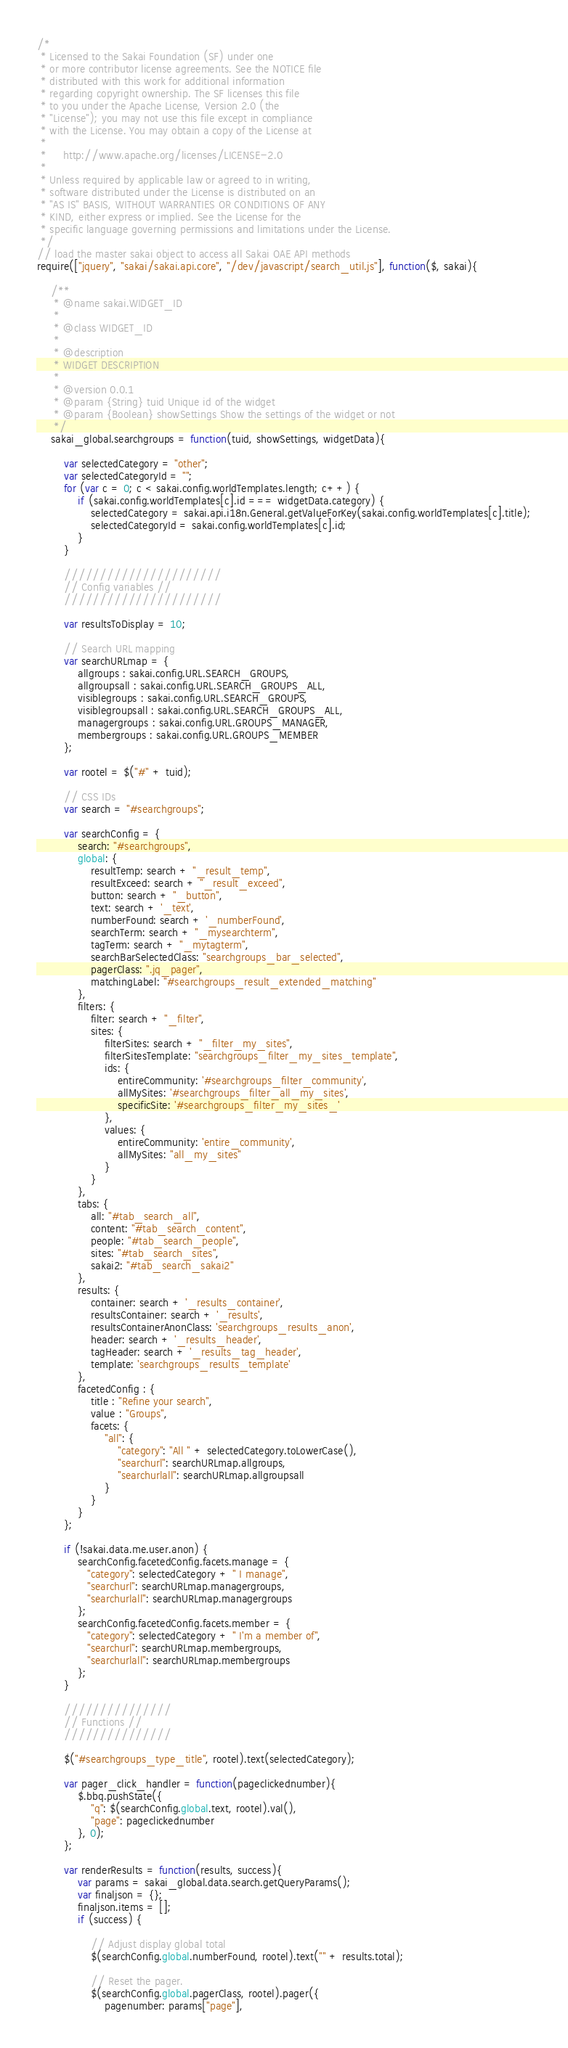Convert code to text. <code><loc_0><loc_0><loc_500><loc_500><_JavaScript_>/*
 * Licensed to the Sakai Foundation (SF) under one
 * or more contributor license agreements. See the NOTICE file
 * distributed with this work for additional information
 * regarding copyright ownership. The SF licenses this file
 * to you under the Apache License, Version 2.0 (the
 * "License"); you may not use this file except in compliance
 * with the License. You may obtain a copy of the License at
 *
 *     http://www.apache.org/licenses/LICENSE-2.0
 *
 * Unless required by applicable law or agreed to in writing,
 * software distributed under the License is distributed on an
 * "AS IS" BASIS, WITHOUT WARRANTIES OR CONDITIONS OF ANY
 * KIND, either express or implied. See the License for the
 * specific language governing permissions and limitations under the License.
 */
// load the master sakai object to access all Sakai OAE API methods
require(["jquery", "sakai/sakai.api.core", "/dev/javascript/search_util.js"], function($, sakai){

    /**
     * @name sakai.WIDGET_ID
     *
     * @class WIDGET_ID
     *
     * @description
     * WIDGET DESCRIPTION
     *
     * @version 0.0.1
     * @param {String} tuid Unique id of the widget
     * @param {Boolean} showSettings Show the settings of the widget or not
     */
    sakai_global.searchgroups = function(tuid, showSettings, widgetData){

        var selectedCategory = "other";
        var selectedCategoryId = "";
        for (var c = 0; c < sakai.config.worldTemplates.length; c++) {
            if (sakai.config.worldTemplates[c].id === widgetData.category) {
                selectedCategory = sakai.api.i18n.General.getValueForKey(sakai.config.worldTemplates[c].title);
                selectedCategoryId = sakai.config.worldTemplates[c].id;
            }
        }

        //////////////////////
        // Config variables //
        //////////////////////

        var resultsToDisplay = 10;

        // Search URL mapping
        var searchURLmap = {
            allgroups : sakai.config.URL.SEARCH_GROUPS,
            allgroupsall : sakai.config.URL.SEARCH_GROUPS_ALL,
            visiblegroups : sakai.config.URL.SEARCH_GROUPS,
            visiblegroupsall : sakai.config.URL.SEARCH_GROUPS_ALL,
            managergroups : sakai.config.URL.GROUPS_MANAGER,
            membergroups : sakai.config.URL.GROUPS_MEMBER
        };

        var rootel = $("#" + tuid);

        // CSS IDs
        var search = "#searchgroups";

        var searchConfig = {
            search: "#searchgroups",
            global: {
                resultTemp: search + "_result_temp",
                resultExceed: search + "_result_exceed",
                button: search + "_button",
                text: search + '_text',
                numberFound: search + '_numberFound',
                searchTerm: search + "_mysearchterm",
                tagTerm: search + "_mytagterm",
                searchBarSelectedClass: "searchgroups_bar_selected",
                pagerClass: ".jq_pager",
                matchingLabel: "#searchgroups_result_extended_matching"
            },
            filters: {
                filter: search + "_filter",
                sites: {
                    filterSites: search + "_filter_my_sites",
                    filterSitesTemplate: "searchgroups_filter_my_sites_template",
                    ids: {
                        entireCommunity: '#searchgroups_filter_community',
                        allMySites: '#searchgroups_filter_all_my_sites',
                        specificSite: '#searchgroups_filter_my_sites_'
                    },
                    values: {
                        entireCommunity: 'entire_community',
                        allMySites: "all_my_sites"
                    }
                }
            },
            tabs: {
                all: "#tab_search_all",
                content: "#tab_search_content",
                people: "#tab_search_people",
                sites: "#tab_search_sites",
                sakai2: "#tab_search_sakai2"
            },
            results: {
                container: search + '_results_container',
                resultsContainer: search + '_results',
                resultsContainerAnonClass: 'searchgroups_results_anon',
                header: search + '_results_header',
                tagHeader: search + '_results_tag_header',
                template: 'searchgroups_results_template'
            },
            facetedConfig : {
                title : "Refine your search",
                value : "Groups",
                facets: {
                    "all": {
                        "category": "All " + selectedCategory.toLowerCase(),
                        "searchurl": searchURLmap.allgroups,
                        "searchurlall": searchURLmap.allgroupsall
                    }
                }
            }
        };

        if (!sakai.data.me.user.anon) {
            searchConfig.facetedConfig.facets.manage = {
               "category": selectedCategory + " I manage",
               "searchurl": searchURLmap.managergroups,
               "searchurlall": searchURLmap.managergroups
            };
            searchConfig.facetedConfig.facets.member = {
               "category": selectedCategory + " I'm a member of",
               "searchurl": searchURLmap.membergroups,
               "searchurlall": searchURLmap.membergroups
            };
        }

        ///////////////
        // Functions //
        ///////////////
        
        $("#searchgroups_type_title", rootel).text(selectedCategory);
    
        var pager_click_handler = function(pageclickednumber){
            $.bbq.pushState({
                "q": $(searchConfig.global.text, rootel).val(),
                "page": pageclickednumber
            }, 0);
        };

        var renderResults = function(results, success){
            var params = sakai_global.data.search.getQueryParams();
            var finaljson = {};
            finaljson.items = [];
            if (success) {

                // Adjust display global total
                $(searchConfig.global.numberFound, rootel).text("" + results.total);

                // Reset the pager.
                $(searchConfig.global.pagerClass, rootel).pager({
                    pagenumber: params["page"],</code> 